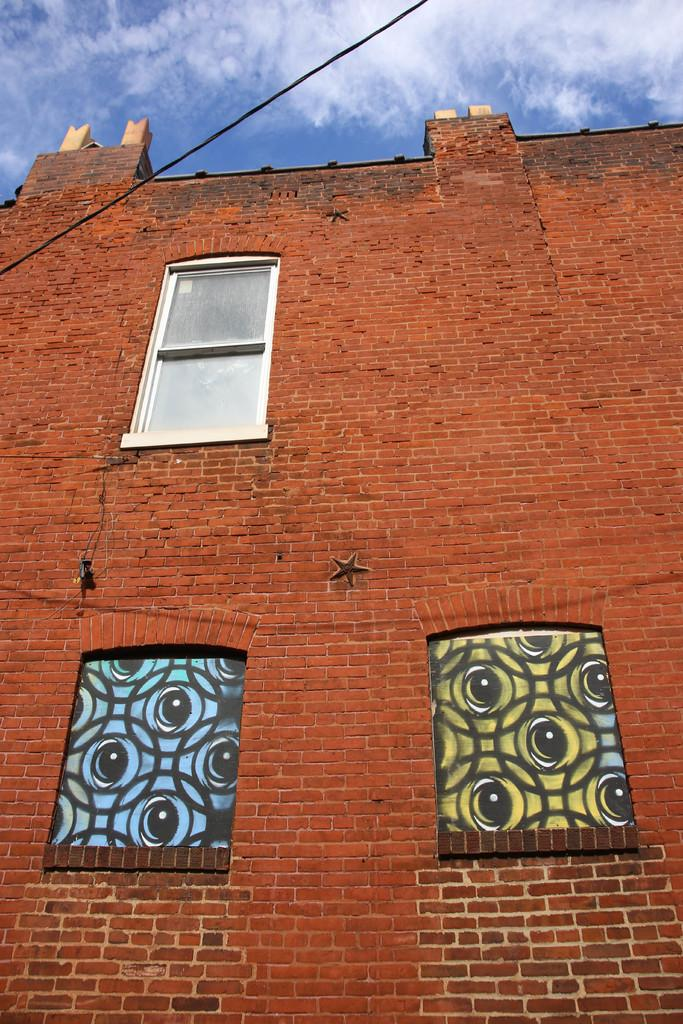Where was the image taken? The image is taken outdoors. What can be seen in the sky in the image? There is a sky visible in the image. What type of structures are present in the image? There are walls and a building in the image. What feature of the building is mentioned in the facts? The building has windows. Can you see a tree jumping in the image? There is no tree or jumping action present in the image. 